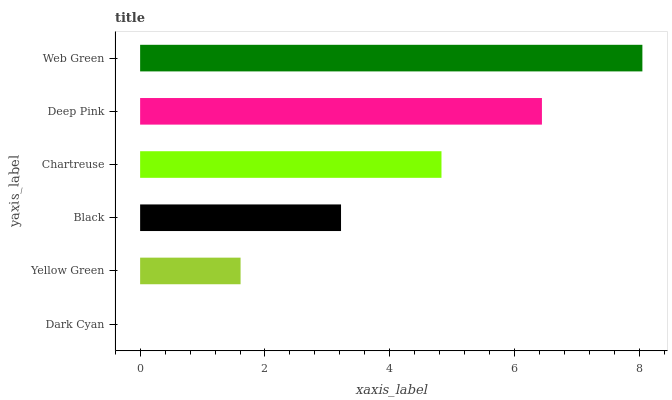Is Dark Cyan the minimum?
Answer yes or no. Yes. Is Web Green the maximum?
Answer yes or no. Yes. Is Yellow Green the minimum?
Answer yes or no. No. Is Yellow Green the maximum?
Answer yes or no. No. Is Yellow Green greater than Dark Cyan?
Answer yes or no. Yes. Is Dark Cyan less than Yellow Green?
Answer yes or no. Yes. Is Dark Cyan greater than Yellow Green?
Answer yes or no. No. Is Yellow Green less than Dark Cyan?
Answer yes or no. No. Is Chartreuse the high median?
Answer yes or no. Yes. Is Black the low median?
Answer yes or no. Yes. Is Black the high median?
Answer yes or no. No. Is Yellow Green the low median?
Answer yes or no. No. 